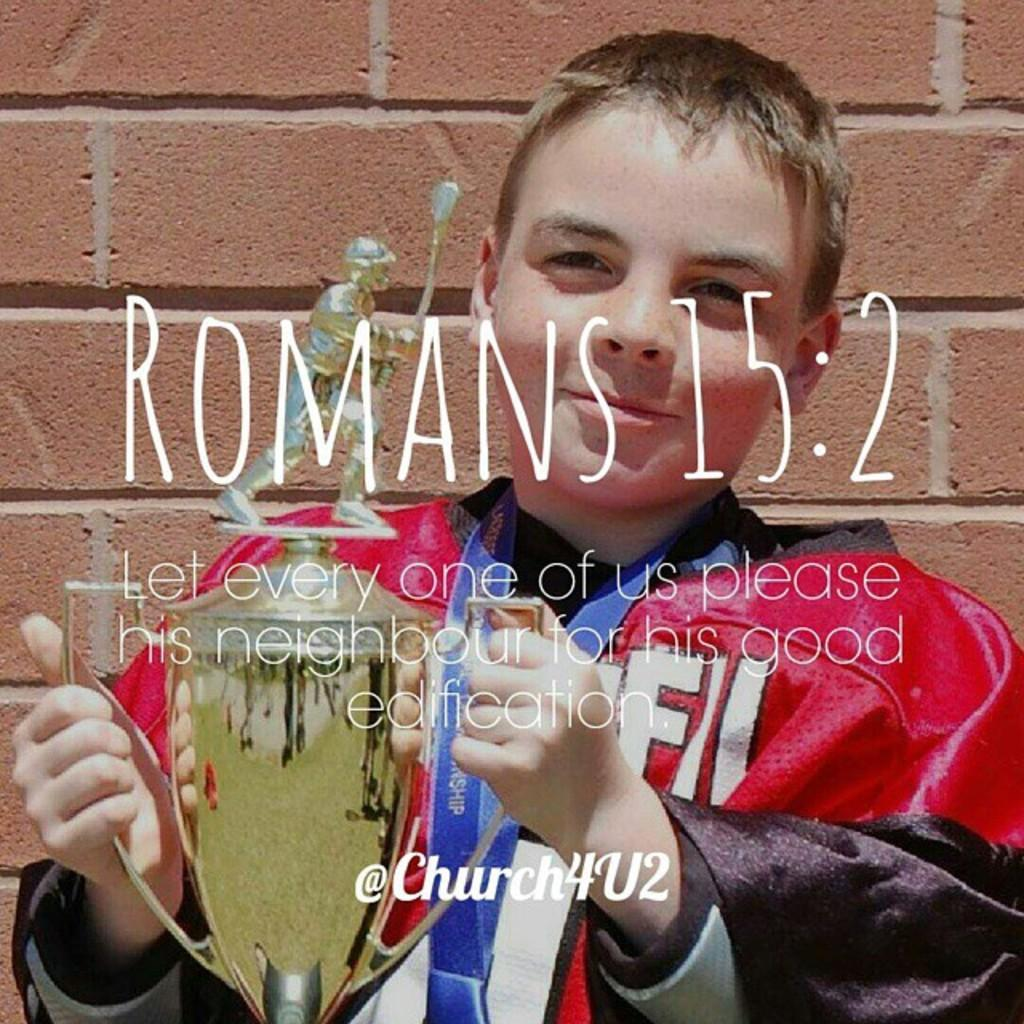<image>
Create a compact narrative representing the image presented. A Romans 15:2 quote is displayed over a photo of a boy with a trophy. 